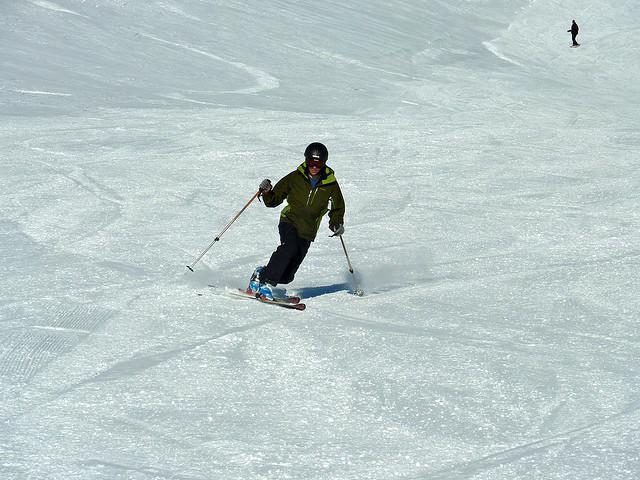How many people are in the picture?
Give a very brief answer. 1. How many slices of pizza are left of the fork?
Give a very brief answer. 0. 